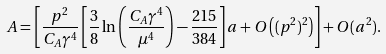<formula> <loc_0><loc_0><loc_500><loc_500>A = \left [ \frac { p ^ { 2 } } { C _ { A } \gamma ^ { 4 } } \left [ \frac { 3 } { 8 } \ln \left ( \frac { C _ { A } \gamma ^ { 4 } } { \mu ^ { 4 } } \right ) - \frac { 2 1 5 } { 3 8 4 } \right ] a + O \left ( ( p ^ { 2 } ) ^ { 2 } \right ) \right ] + O ( a ^ { 2 } ) .</formula> 